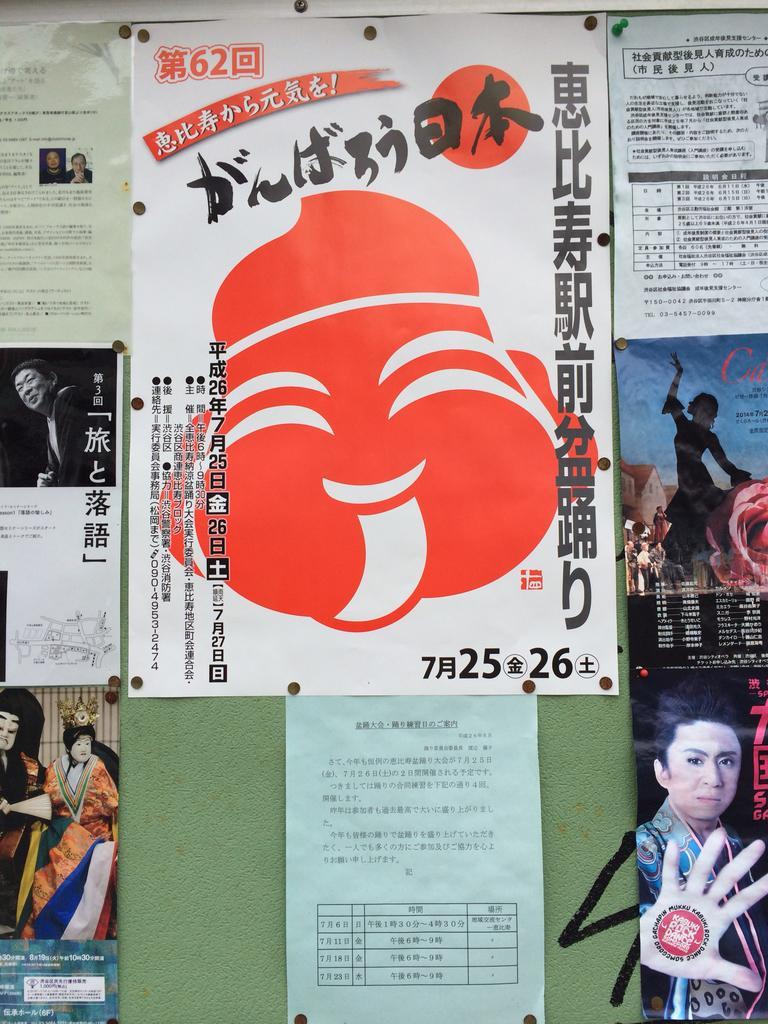Please provide a concise description of this image. In this picture I can see number of posters in front and on it I can see something is written and I can also see few images of persons and I can see the pins. 